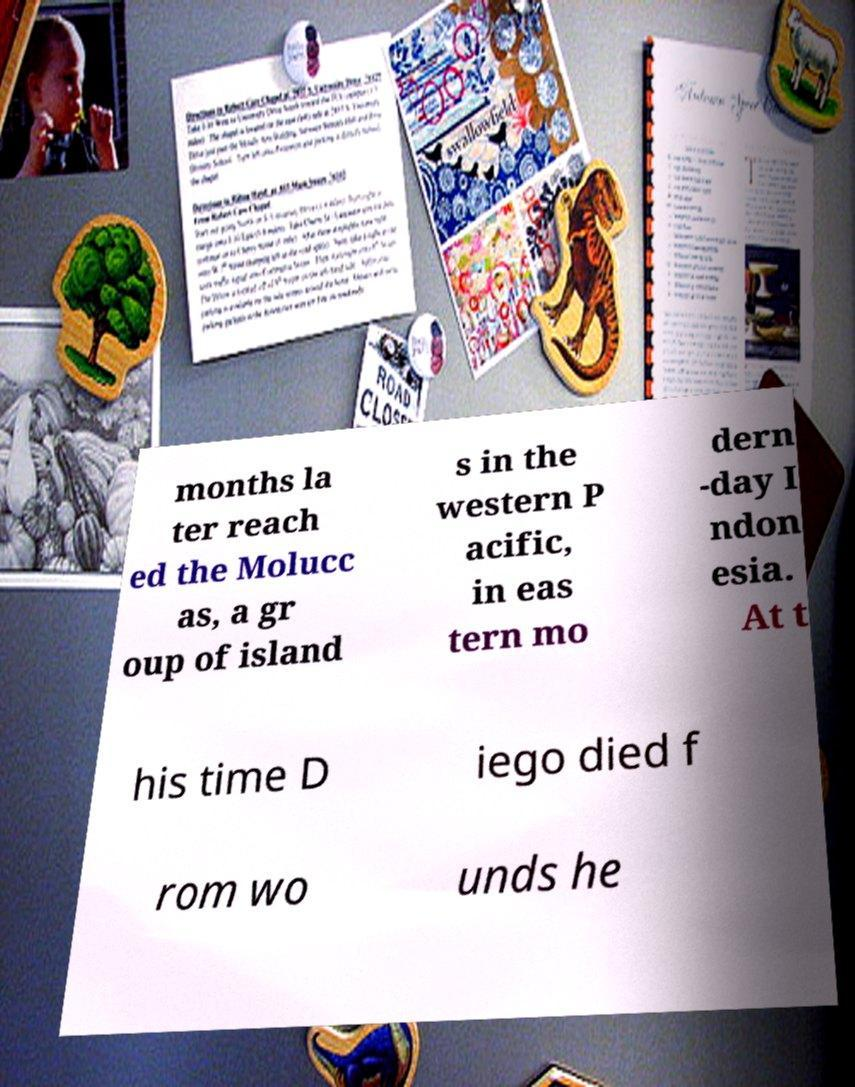Can you read and provide the text displayed in the image?This photo seems to have some interesting text. Can you extract and type it out for me? months la ter reach ed the Molucc as, a gr oup of island s in the western P acific, in eas tern mo dern -day I ndon esia. At t his time D iego died f rom wo unds he 